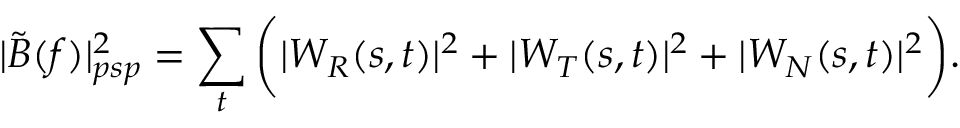Convert formula to latex. <formula><loc_0><loc_0><loc_500><loc_500>| \tilde { B } ( f ) | _ { p s p } ^ { 2 } = \sum _ { t } \left ( | W _ { R } ( s , t ) | ^ { 2 } + | W _ { T } ( s , t ) | ^ { 2 } + | W _ { N } ( s , t ) | ^ { 2 } \right ) .</formula> 